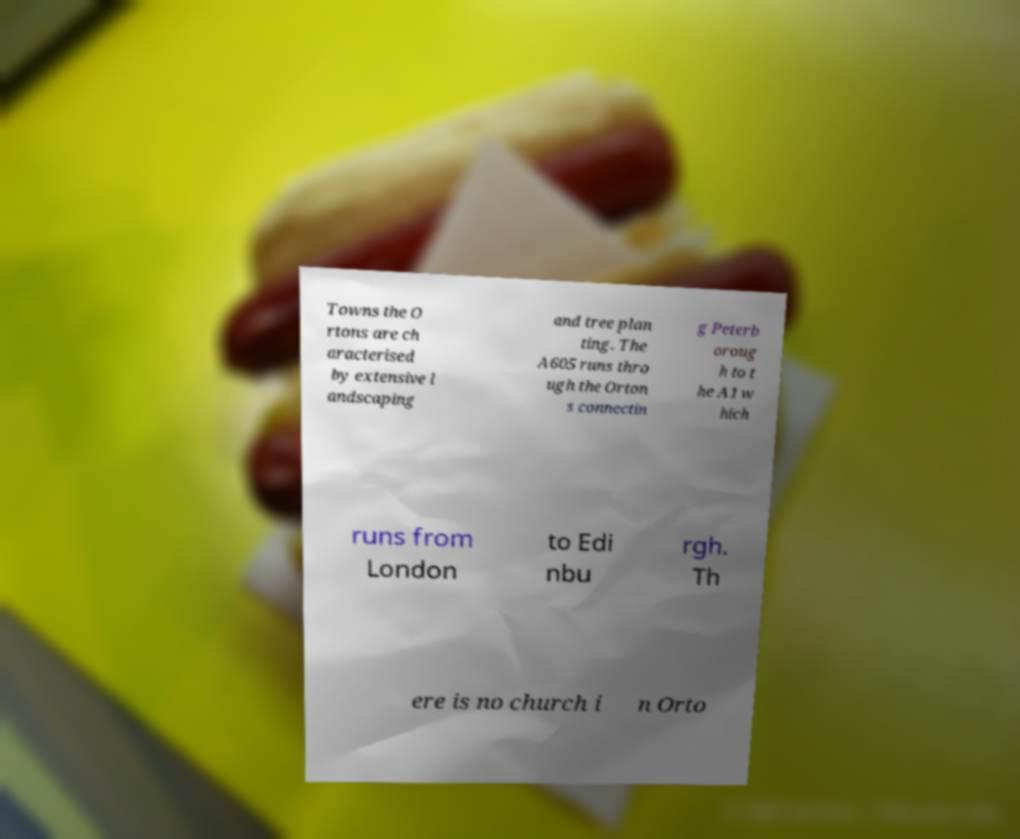I need the written content from this picture converted into text. Can you do that? Towns the O rtons are ch aracterised by extensive l andscaping and tree plan ting. The A605 runs thro ugh the Orton s connectin g Peterb oroug h to t he A1 w hich runs from London to Edi nbu rgh. Th ere is no church i n Orto 